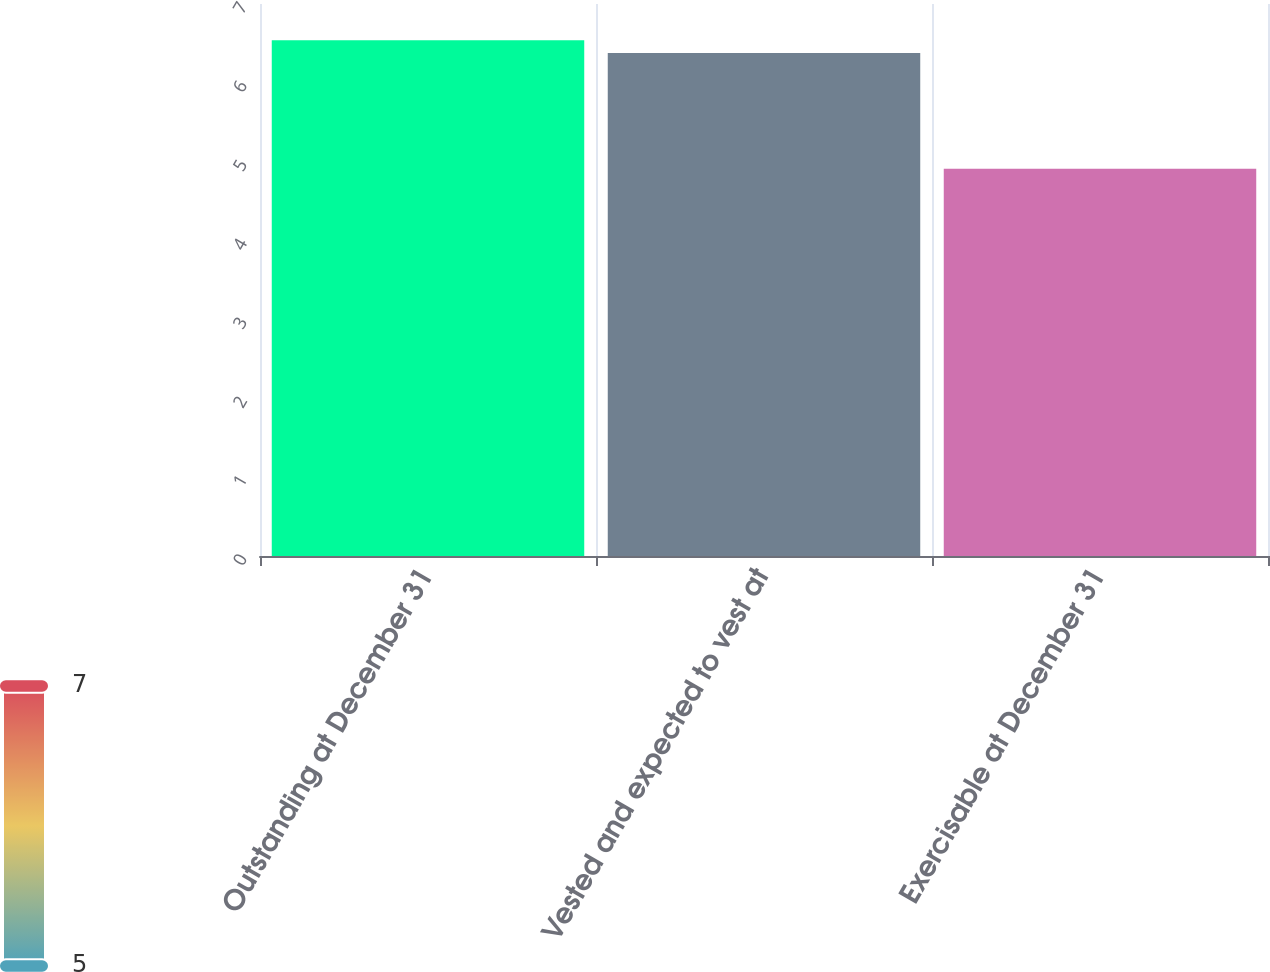<chart> <loc_0><loc_0><loc_500><loc_500><bar_chart><fcel>Outstanding at December 31<fcel>Vested and expected to vest at<fcel>Exercisable at December 31<nl><fcel>6.54<fcel>6.38<fcel>4.91<nl></chart> 